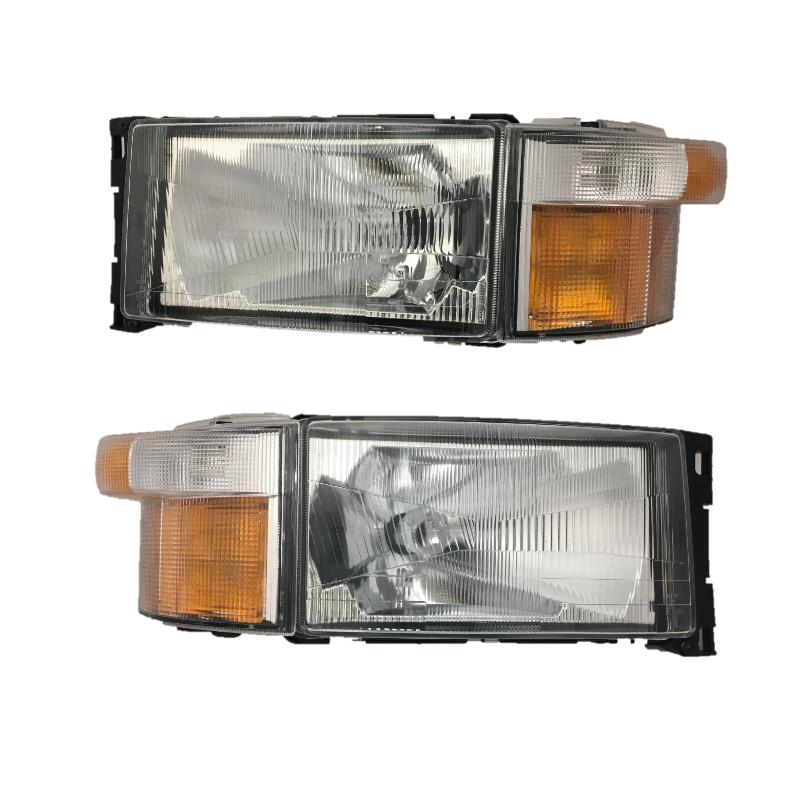Based on the design and orientation of these headlamps, what can we infer about the type of vehicle they are designed for and the market or region they are intended to be used in? The headlamps, with their clear distinction between the main lighting and the amber turn signals, are characteristic of vehicles designed for specific international markets, notably the United States. These lights exhibit a design requiring separate functions for the main and signal lights, a requirement in regions with stringent vehicle safety and visibility regulations. This type of headlamp design not only ensures compliance with local vehicular laws but also enhances on-road safety by clearly indicating vehicle actions to other road users. The presence of robust, transparent casings suggests they are intended for use in environments that may also demand high durability and resistance to varying weather conditions. 